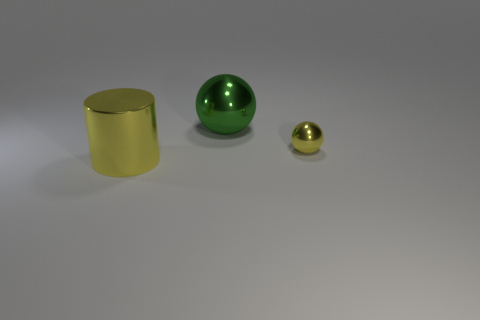Add 3 yellow spheres. How many objects exist? 6 Subtract all cylinders. How many objects are left? 2 Add 1 small things. How many small things are left? 2 Add 1 yellow shiny objects. How many yellow shiny objects exist? 3 Subtract 0 red spheres. How many objects are left? 3 Subtract all blue metallic cubes. Subtract all large metallic cylinders. How many objects are left? 2 